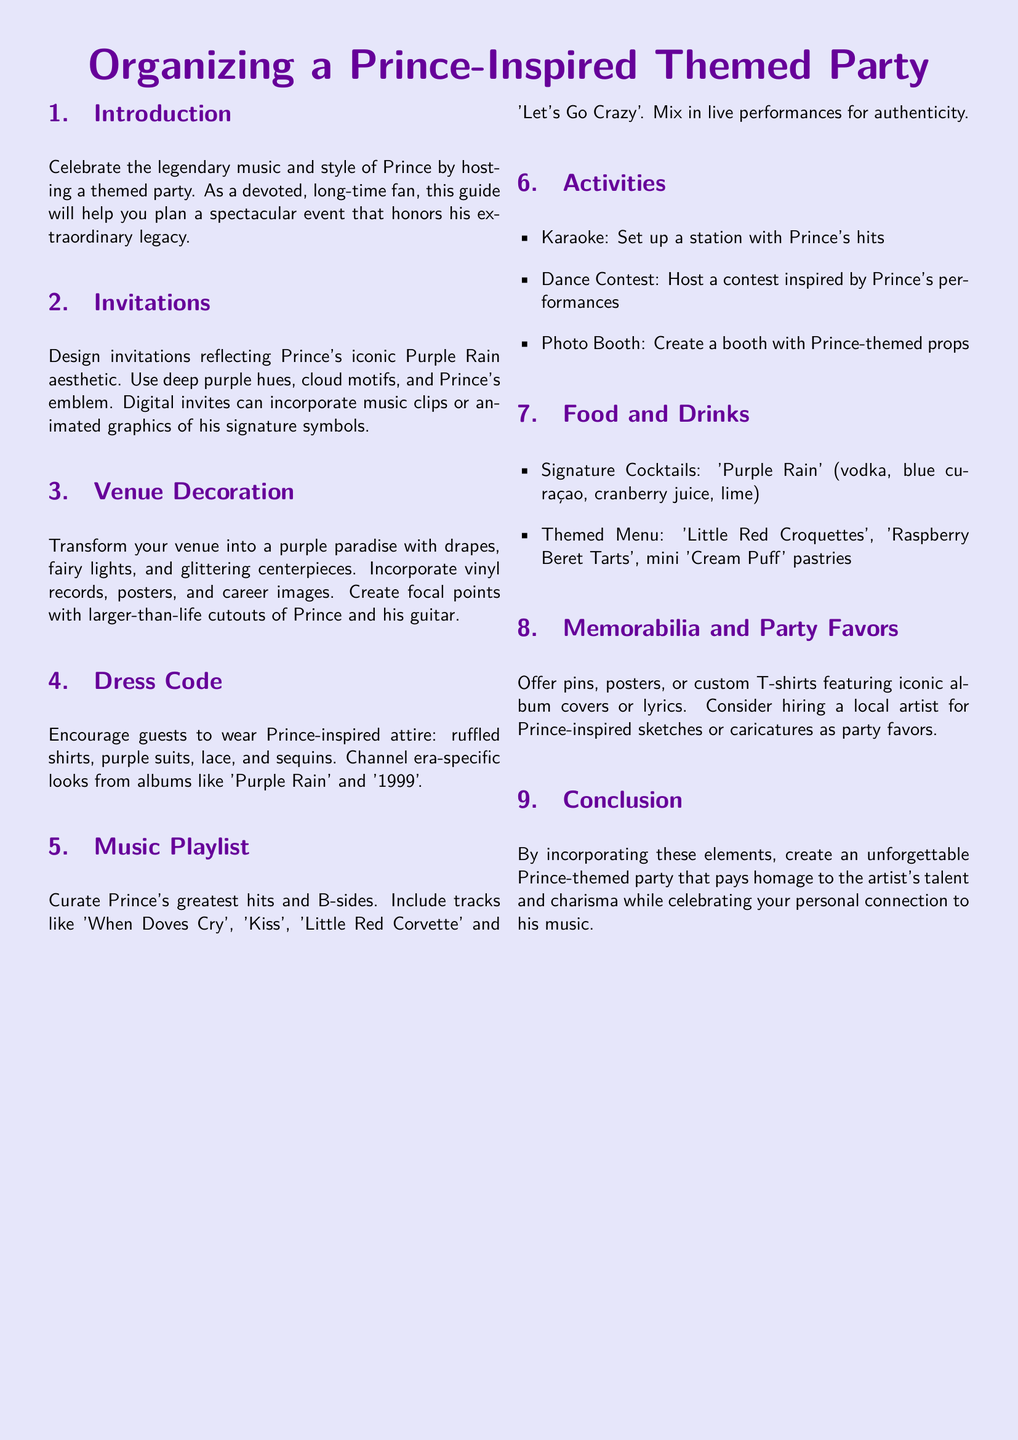What is the primary color theme for the invitations? The invitations should reflect the iconic Purple Rain aesthetic, which predominantly features deep purple hues.
Answer: deep purple Name one of the suggested activities for the party. The document lists activities such as karaoke.
Answer: karaoke What are two signature cocktails mentioned? The guide specifically mentions 'Purple Rain' as one of the signature cocktails.
Answer: Purple Rain Which album's era-specific looks should guests consider for their attire? Guests are encouraged to channel looks from the album 'Purple Rain'.
Answer: Purple Rain What type of decorations are recommended for the venue? Transform the venue into a purple paradise with drapes, fairy lights, and glittering centerpieces.
Answer: drapes, fairy lights How many items are listed under the Food and Drinks section? The document outlines two specific items under Food and Drinks: 'Purple Rain' and a themed menu.
Answer: two What should be incorporated into the digital invitations? Digital invites can incorporate music clips or animated graphics of his signature symbols.
Answer: music clips What is recommended for party favors? Offer pins, posters, or custom T-shirts featuring iconic album covers or lyrics as party favors.
Answer: pins, posters, custom T-shirts How many activities are listed in the Activities section? The Activities section includes three specific activities listed in bullet points.
Answer: three What is the goal of the themed party according to the introduction? The introduction states that the aim is to celebrate Prince's music and style.
Answer: celebrate Prince's music and style 